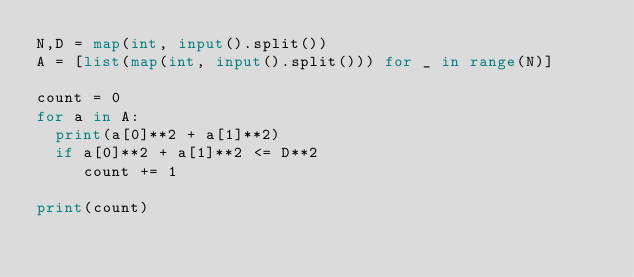<code> <loc_0><loc_0><loc_500><loc_500><_Python_>N,D = map(int, input().split())
A = [list(map(int, input().split())) for _ in range(N)]

count = 0
for a in A:
  print(a[0]**2 + a[1]**2)
  if a[0]**2 + a[1]**2 <= D**2
     count += 1

print(count)</code> 